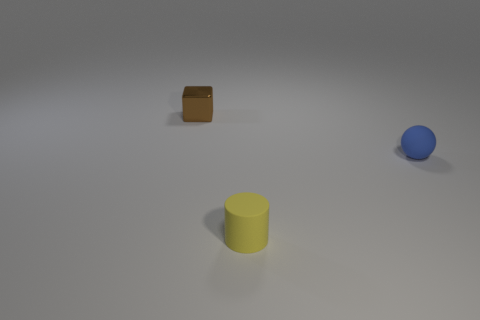Do the brown metal cube and the blue matte sphere have the same size?
Provide a short and direct response. Yes. Are any large yellow balls visible?
Give a very brief answer. No. What number of other balls have the same color as the tiny rubber ball?
Make the answer very short. 0. Are the sphere and the small thing behind the sphere made of the same material?
Your response must be concise. No. Is the number of tiny objects that are to the left of the yellow cylinder greater than the number of brown spheres?
Your answer should be very brief. Yes. Are there the same number of objects that are behind the brown shiny block and small balls on the left side of the small blue thing?
Ensure brevity in your answer.  Yes. There is a cylinder that is on the left side of the blue ball; what material is it?
Offer a very short reply. Rubber. How many things are either tiny things that are to the left of the tiny blue object or yellow matte cylinders?
Keep it short and to the point. 2. What number of other objects are the same shape as the small yellow rubber object?
Offer a terse response. 0. There is a small blue rubber thing; are there any small matte spheres behind it?
Give a very brief answer. No. 